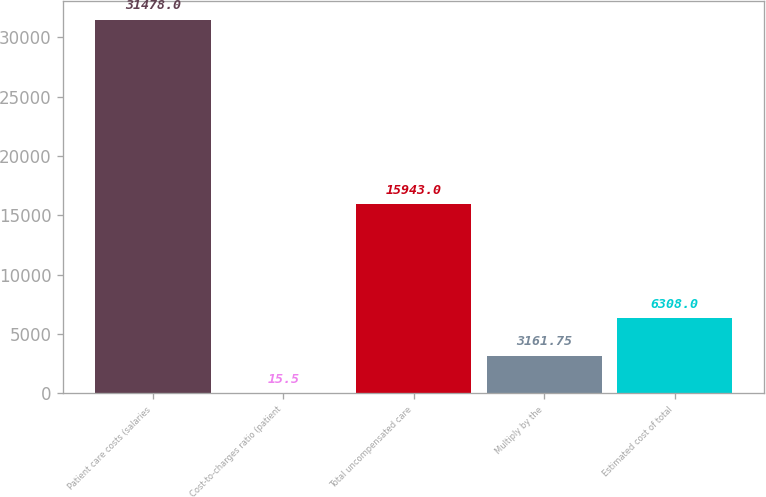<chart> <loc_0><loc_0><loc_500><loc_500><bar_chart><fcel>Patient care costs (salaries<fcel>Cost-to-charges ratio (patient<fcel>Total uncompensated care<fcel>Multiply by the<fcel>Estimated cost of total<nl><fcel>31478<fcel>15.5<fcel>15943<fcel>3161.75<fcel>6308<nl></chart> 